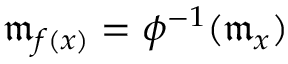Convert formula to latex. <formula><loc_0><loc_0><loc_500><loc_500>{ \mathfrak { m } } _ { f ( x ) } = \phi ^ { - 1 } ( { \mathfrak { m } } _ { x } )</formula> 